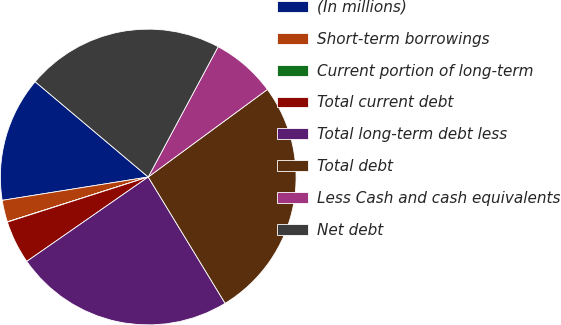Convert chart. <chart><loc_0><loc_0><loc_500><loc_500><pie_chart><fcel>(In millions)<fcel>Short-term borrowings<fcel>Current portion of long-term<fcel>Total current debt<fcel>Total long-term debt less<fcel>Total debt<fcel>Less Cash and cash equivalents<fcel>Net debt<nl><fcel>13.67%<fcel>2.38%<fcel>0.03%<fcel>4.73%<fcel>24.04%<fcel>26.38%<fcel>7.08%<fcel>21.69%<nl></chart> 